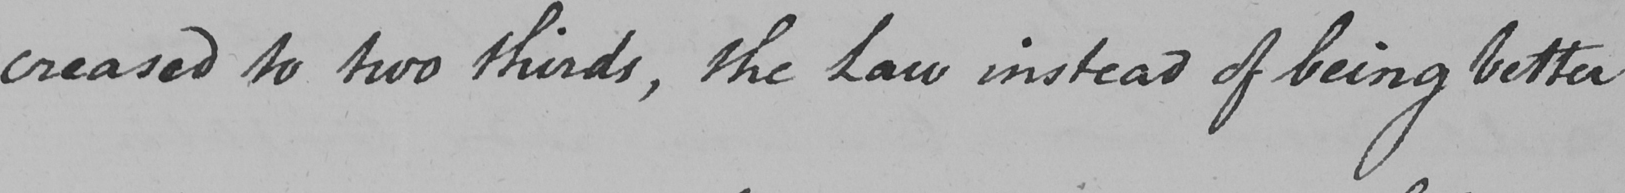Can you tell me what this handwritten text says? -creased to two thirds , the Law instead of being better 